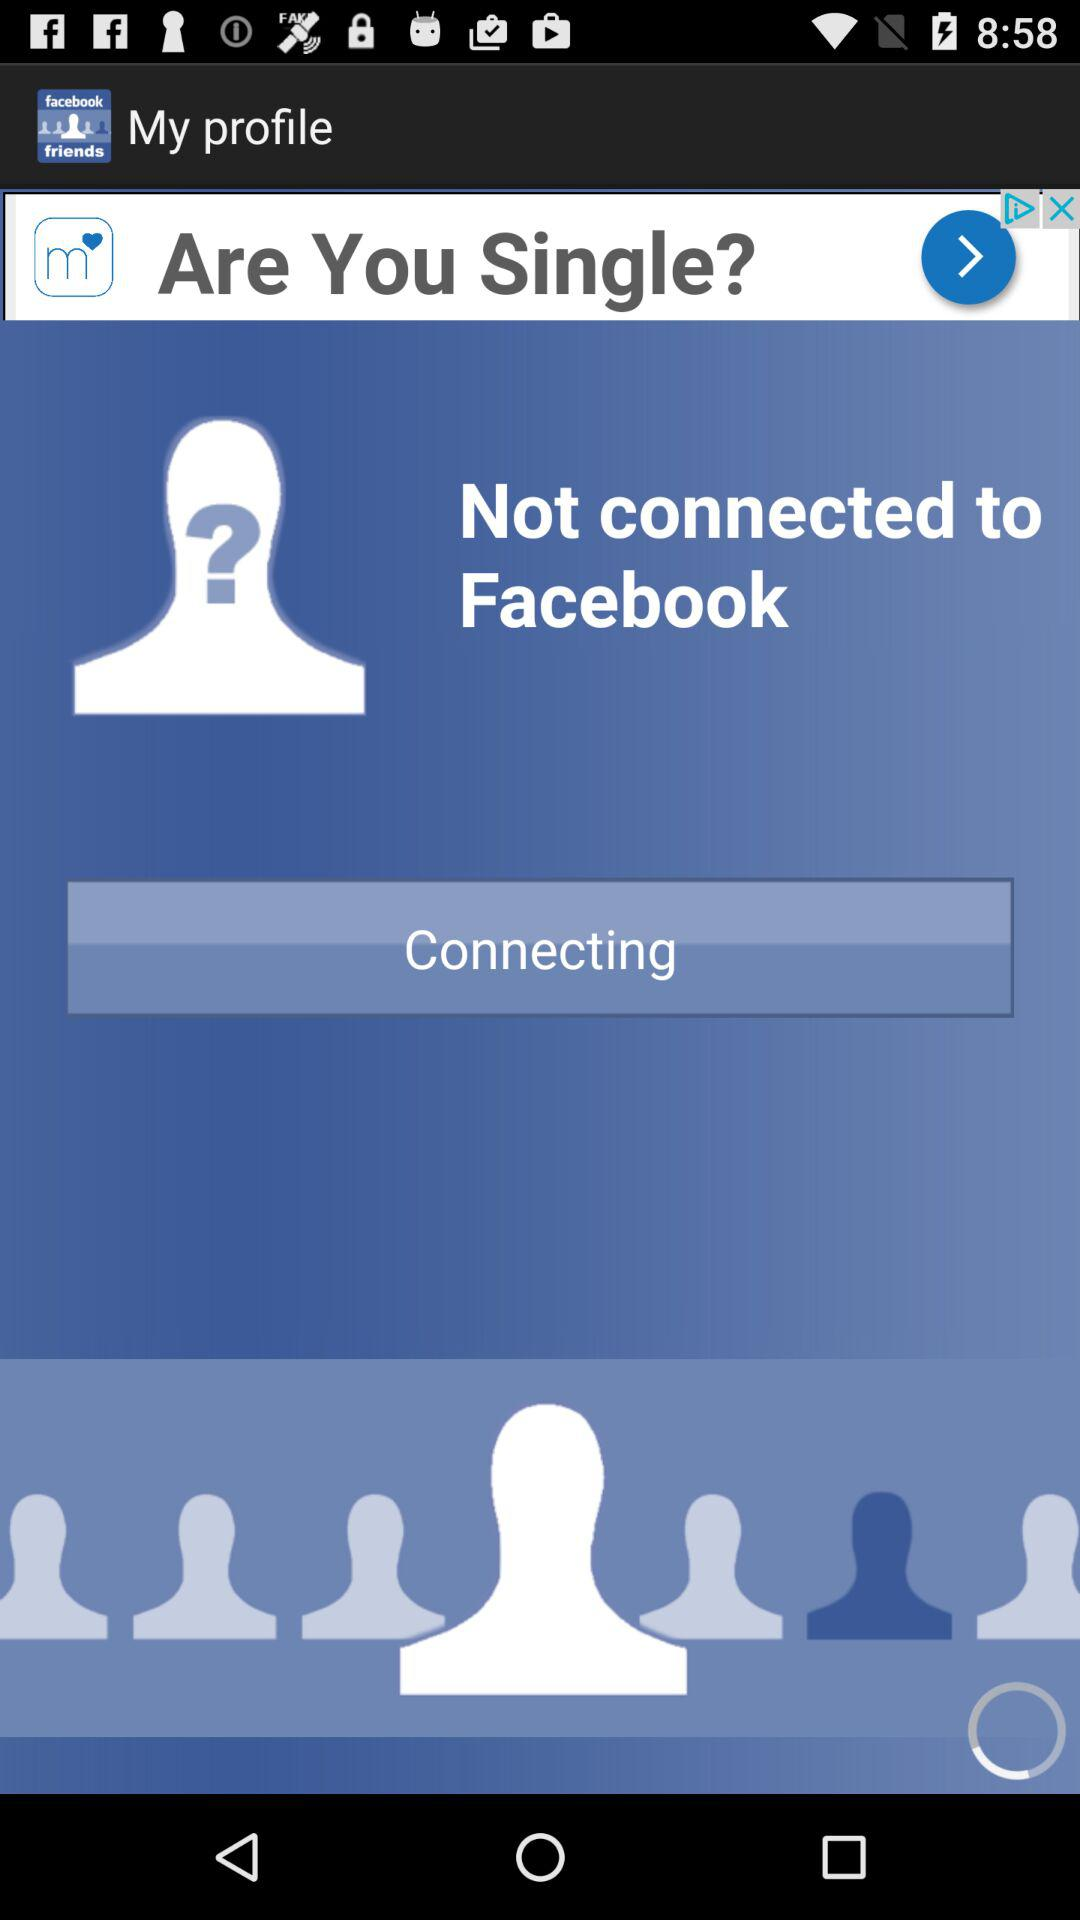What application is the user trying to connect to? The user is trying to connect to "Facebook". 